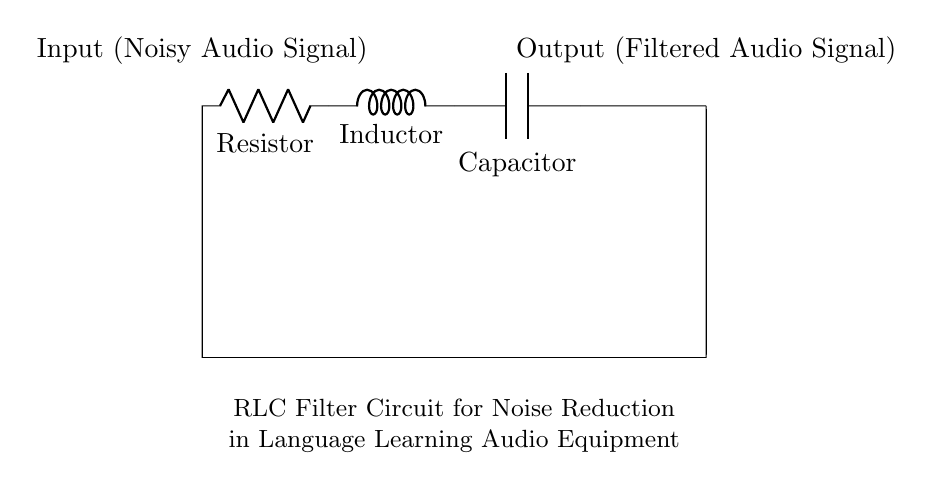What is the first component in the circuit? The first component is a resistor, located at the leftmost part of the circuit diagram. It is marked as 'R'.
Answer: Resistor What is the last component in the circuit? The last component is a capacitor, located at the rightmost part of the circuit diagram. It is marked as 'C'.
Answer: Capacitor How many components are there in total? There are three main components: a resistor, an inductor, and a capacitor. Counting them gives a total of three components.
Answer: Three What is the function of this circuit? The primary function of this circuit is noise reduction in audio signals, which is indicated in the description text below the circuit.
Answer: Noise reduction Which components form a series connection? The resistor, inductor, and capacitor are all connected in series as they are placed along the same path without branching.
Answer: Resistor, Inductor, Capacitor What type of filter does this circuit represent? This circuit represents an RLC filter, which is specifically designed to filter signals, as indicated by the components and their arrangement.
Answer: RLC filter How does the inductor contribute to the filtering process? The inductor opposes changes in current, which helps to smooth out fluctuations in the audio signal, thus contributing to the filtering process in combination with the resistor and capacitor.
Answer: Smoothing fluctuations 